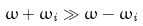Convert formula to latex. <formula><loc_0><loc_0><loc_500><loc_500>\omega + \omega _ { i } \gg \omega - \omega _ { i }</formula> 